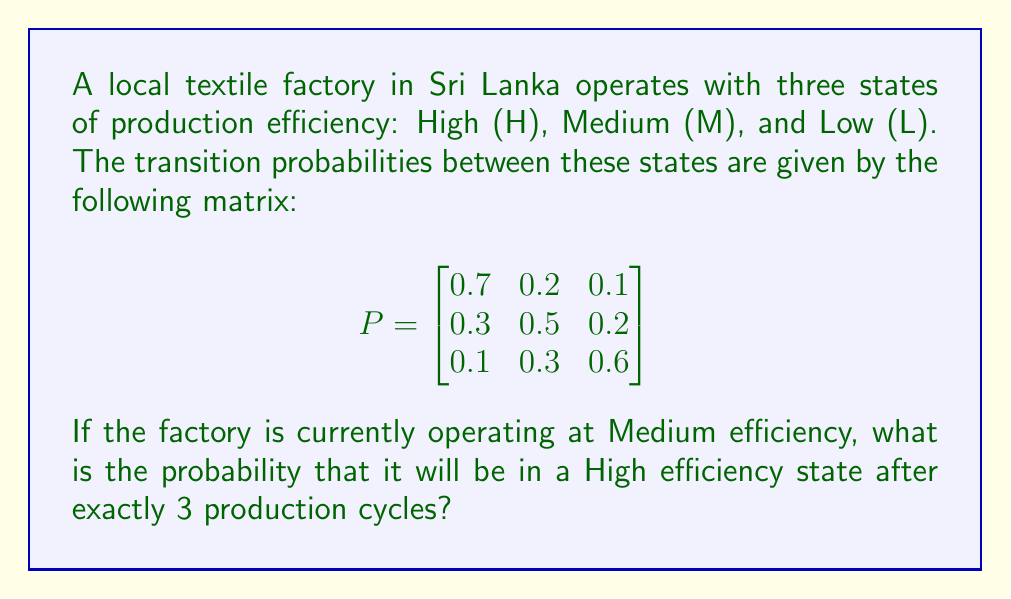Show me your answer to this math problem. To solve this problem, we need to use the Chapman-Kolmogorov equations and the properties of Markov chains. Let's approach this step-by-step:

1) First, we need to identify the initial state vector. Since the factory is currently at Medium efficiency, our initial state vector is:

   $$\pi_0 = \begin{bmatrix} 0 & 1 & 0 \end{bmatrix}$$

2) We want to find the state after 3 production cycles. In Markov chain theory, this is equivalent to raising the transition matrix to the power of 3:

   $$P^3 = P \times P \times P$$

3) Let's calculate $P^3$:

   $$P^2 = \begin{bmatrix}
   0.58 & 0.26 & 0.16 \\
   0.37 & 0.43 & 0.20 \\
   0.22 & 0.33 & 0.45
   \end{bmatrix}$$

   $$P^3 = \begin{bmatrix}
   0.526 & 0.284 & 0.190 \\
   0.421 & 0.353 & 0.226 \\
   0.313 & 0.333 & 0.354
   \end{bmatrix}$$

4) Now, we need to multiply our initial state vector by $P^3$:

   $$\pi_3 = \pi_0 \times P^3 = \begin{bmatrix} 0 & 1 & 0 \end{bmatrix} \times \begin{bmatrix}
   0.526 & 0.284 & 0.190 \\
   0.421 & 0.353 & 0.226 \\
   0.313 & 0.333 & 0.354
   \end{bmatrix}$$

5) This multiplication gives us:

   $$\pi_3 = \begin{bmatrix} 0.421 & 0.353 & 0.226 \end{bmatrix}$$

6) The probability of being in the High efficiency state after 3 cycles is the first element of this vector.
Answer: 0.421 